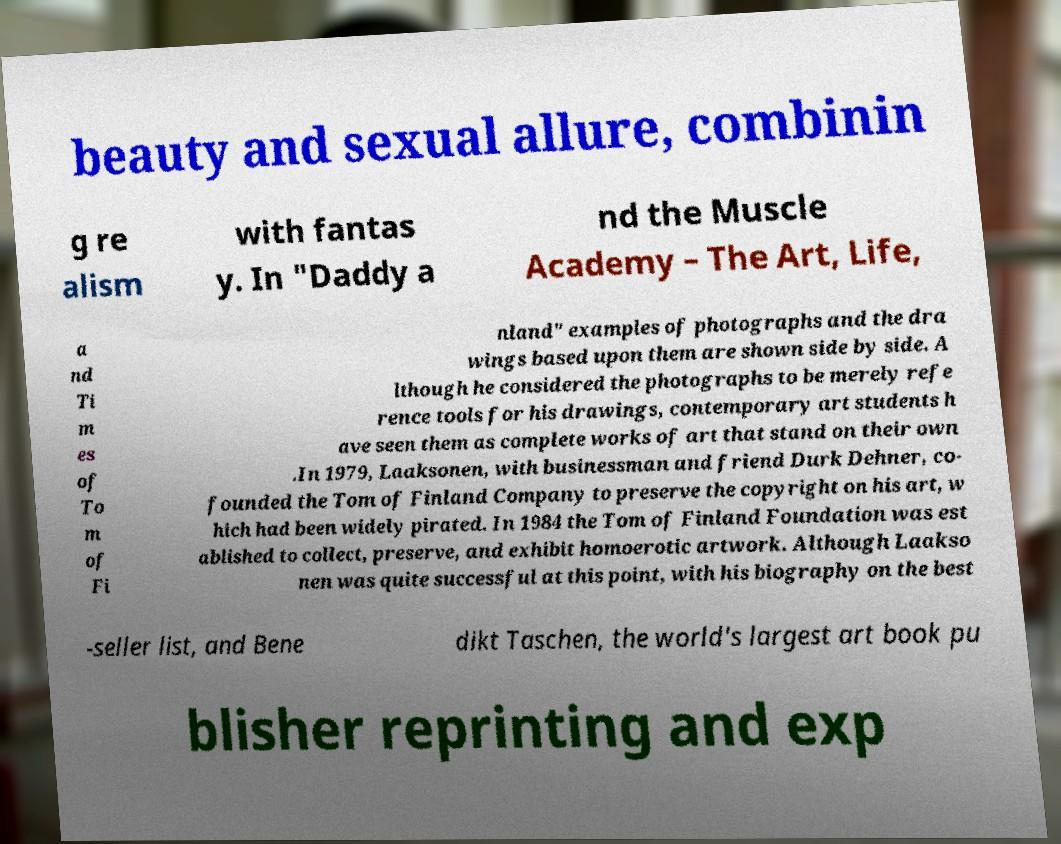Please identify and transcribe the text found in this image. beauty and sexual allure, combinin g re alism with fantas y. In "Daddy a nd the Muscle Academy – The Art, Life, a nd Ti m es of To m of Fi nland" examples of photographs and the dra wings based upon them are shown side by side. A lthough he considered the photographs to be merely refe rence tools for his drawings, contemporary art students h ave seen them as complete works of art that stand on their own .In 1979, Laaksonen, with businessman and friend Durk Dehner, co- founded the Tom of Finland Company to preserve the copyright on his art, w hich had been widely pirated. In 1984 the Tom of Finland Foundation was est ablished to collect, preserve, and exhibit homoerotic artwork. Although Laakso nen was quite successful at this point, with his biography on the best -seller list, and Bene dikt Taschen, the world's largest art book pu blisher reprinting and exp 